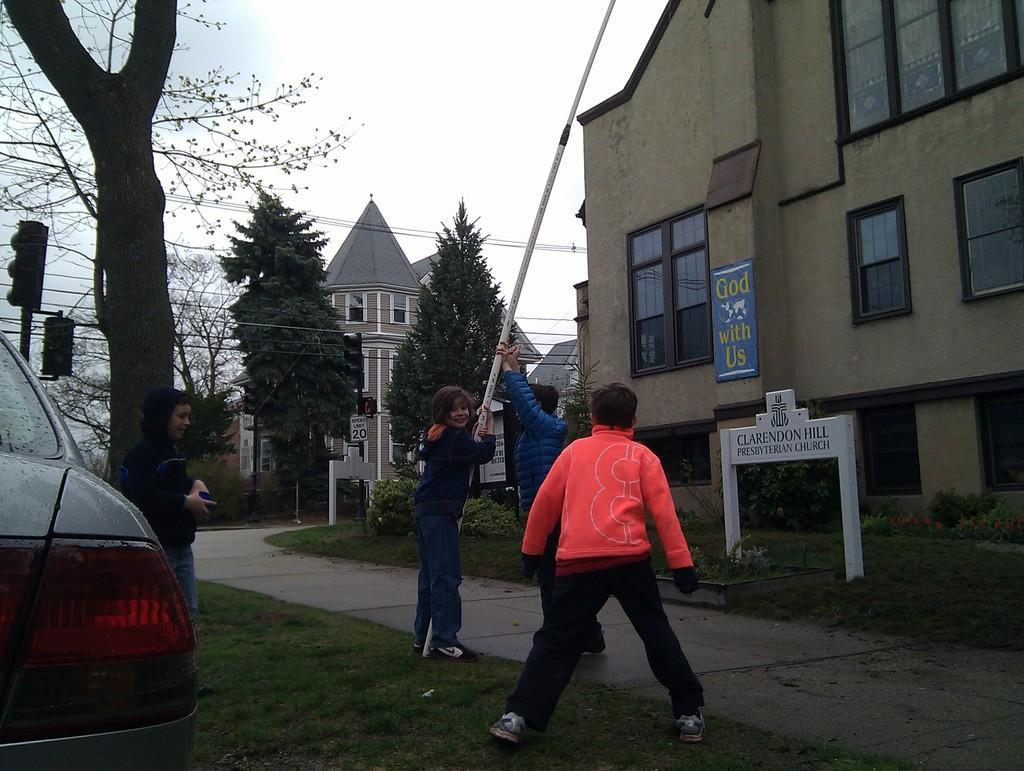How would you summarize this image in a sentence or two? In this picture we can find few kids, they are standing on the grass, beside to the kids we can find a car, trees and traffic lights, in the background we can see few houses, and cables. 